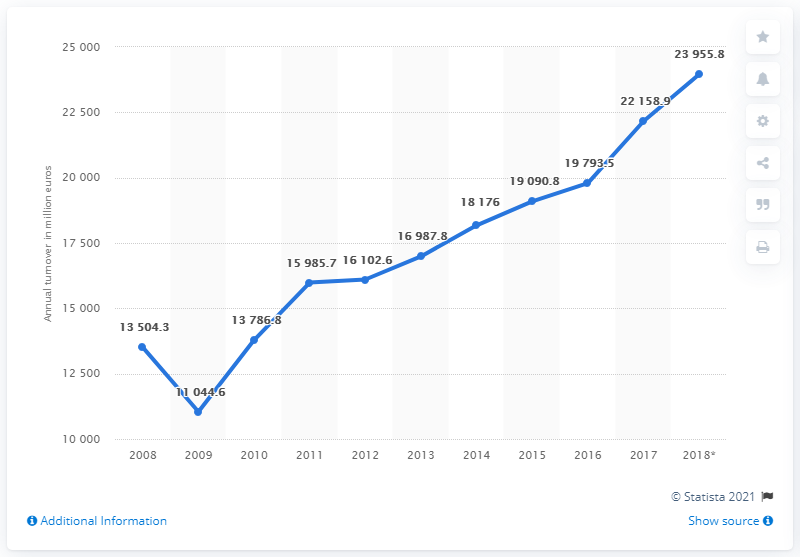Draw attention to some important aspects in this diagram. In 2017, the turnover of the Polish manufacturing of rubber and plastic products was 22,158.9 million złotys. 